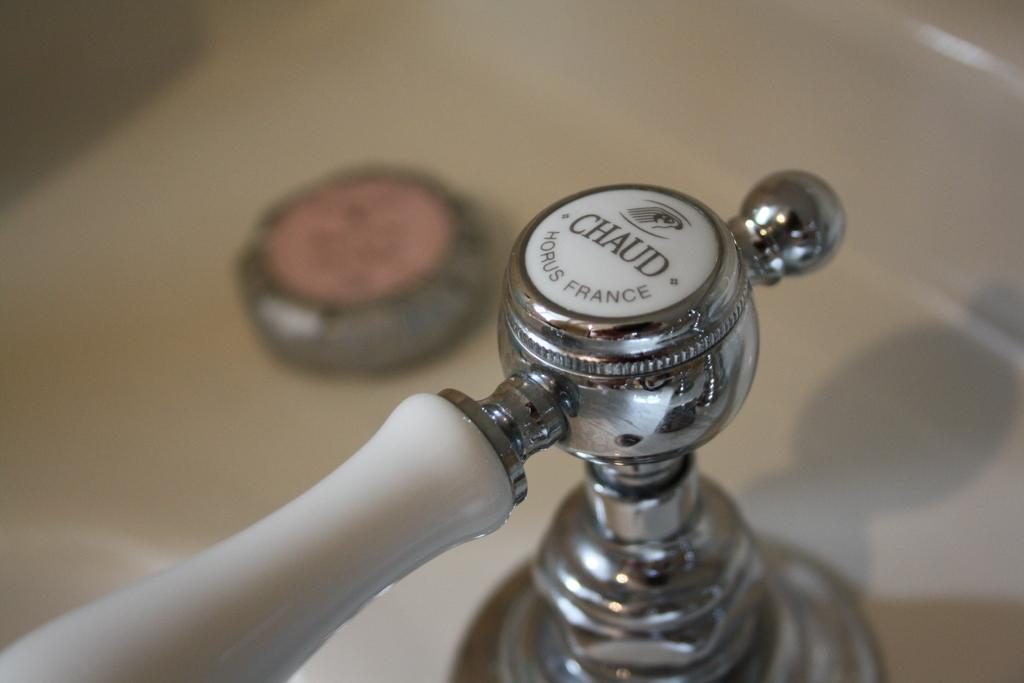What is located in the center of the image? There is a sink in the center of the image. What feature is present on the sink in the image? There is a tap in the image. How many scales can be seen on the pies in the image? There are no pies present in the image, and therefore no scales can be seen on them. 